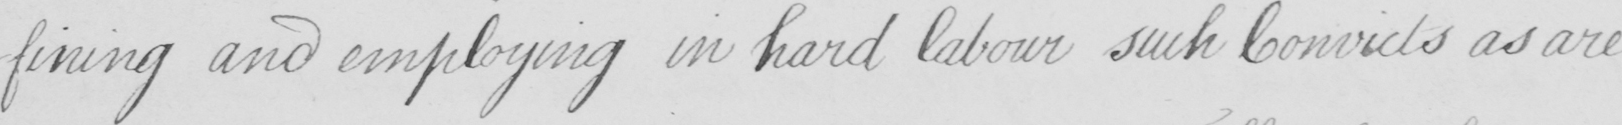What is written in this line of handwriting? -fining and employing in hard labour such Convicts as are 